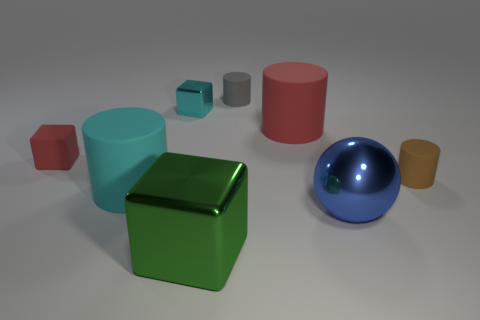How many metal things are either objects or big green cylinders?
Your answer should be compact. 3. The blue metallic sphere is what size?
Offer a terse response. Large. What number of objects are either tiny blue metallic blocks or big cylinders left of the big block?
Provide a succinct answer. 1. What number of other things are the same color as the matte cube?
Provide a short and direct response. 1. There is a brown thing; is it the same size as the red object on the left side of the cyan block?
Ensure brevity in your answer.  Yes. There is a matte cylinder on the left side of the green shiny cube; does it have the same size as the large green block?
Your response must be concise. Yes. What number of other objects are the same material as the cyan cylinder?
Your answer should be compact. 4. Is the number of small matte objects that are in front of the small brown cylinder the same as the number of tiny cyan shiny things to the right of the large green thing?
Your answer should be very brief. Yes. There is a block that is left of the large cylinder that is left of the shiny object that is left of the large green metal cube; what is its color?
Provide a short and direct response. Red. There is a shiny thing to the right of the tiny gray thing; what is its shape?
Your response must be concise. Sphere. 